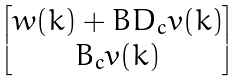Convert formula to latex. <formula><loc_0><loc_0><loc_500><loc_500>\begin{bmatrix} w ( k ) + B D _ { c } v ( k ) \\ B _ { c } v ( k ) \end{bmatrix}</formula> 